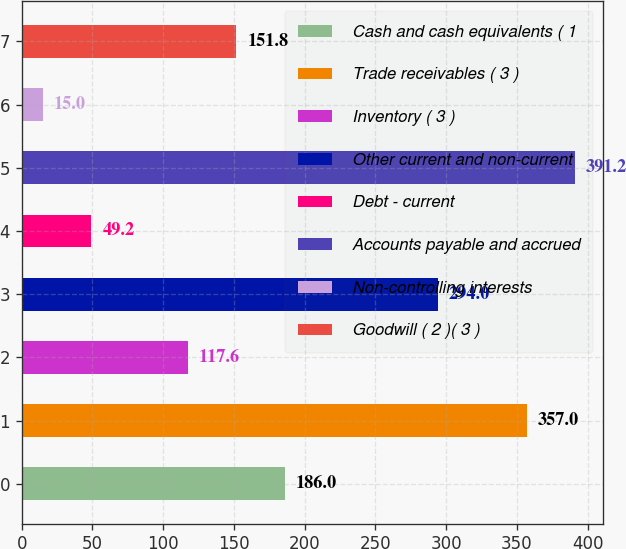Convert chart. <chart><loc_0><loc_0><loc_500><loc_500><bar_chart><fcel>Cash and cash equivalents ( 1<fcel>Trade receivables ( 3 )<fcel>Inventory ( 3 )<fcel>Other current and non-current<fcel>Debt - current<fcel>Accounts payable and accrued<fcel>Non-controlling interests<fcel>Goodwill ( 2 )( 3 )<nl><fcel>186<fcel>357<fcel>117.6<fcel>294<fcel>49.2<fcel>391.2<fcel>15<fcel>151.8<nl></chart> 